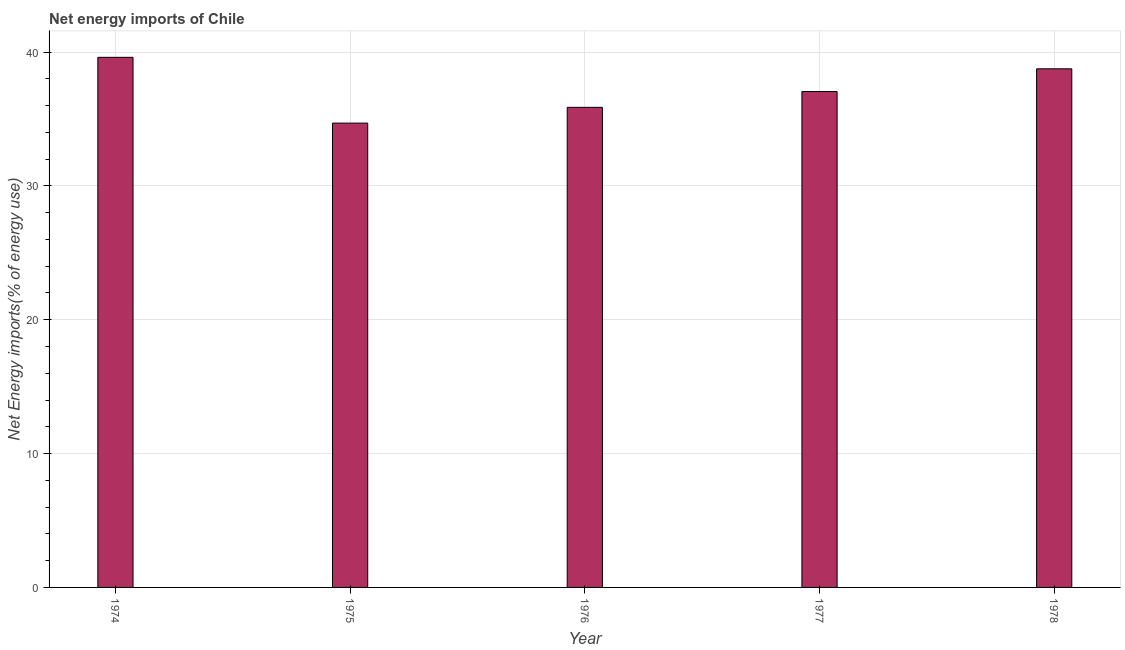Does the graph contain any zero values?
Your answer should be very brief. No. What is the title of the graph?
Your answer should be very brief. Net energy imports of Chile. What is the label or title of the X-axis?
Offer a terse response. Year. What is the label or title of the Y-axis?
Your answer should be very brief. Net Energy imports(% of energy use). What is the energy imports in 1976?
Your answer should be very brief. 35.87. Across all years, what is the maximum energy imports?
Your answer should be compact. 39.61. Across all years, what is the minimum energy imports?
Provide a succinct answer. 34.69. In which year was the energy imports maximum?
Your answer should be compact. 1974. In which year was the energy imports minimum?
Give a very brief answer. 1975. What is the sum of the energy imports?
Keep it short and to the point. 185.97. What is the difference between the energy imports in 1975 and 1978?
Give a very brief answer. -4.06. What is the average energy imports per year?
Provide a short and direct response. 37.19. What is the median energy imports?
Give a very brief answer. 37.05. In how many years, is the energy imports greater than 28 %?
Offer a very short reply. 5. What is the ratio of the energy imports in 1975 to that in 1978?
Give a very brief answer. 0.9. What is the difference between the highest and the second highest energy imports?
Your answer should be compact. 0.86. Is the sum of the energy imports in 1975 and 1978 greater than the maximum energy imports across all years?
Make the answer very short. Yes. What is the difference between the highest and the lowest energy imports?
Your response must be concise. 4.91. In how many years, is the energy imports greater than the average energy imports taken over all years?
Ensure brevity in your answer.  2. What is the difference between two consecutive major ticks on the Y-axis?
Make the answer very short. 10. Are the values on the major ticks of Y-axis written in scientific E-notation?
Provide a short and direct response. No. What is the Net Energy imports(% of energy use) of 1974?
Make the answer very short. 39.61. What is the Net Energy imports(% of energy use) in 1975?
Your response must be concise. 34.69. What is the Net Energy imports(% of energy use) in 1976?
Give a very brief answer. 35.87. What is the Net Energy imports(% of energy use) in 1977?
Your response must be concise. 37.05. What is the Net Energy imports(% of energy use) of 1978?
Provide a succinct answer. 38.75. What is the difference between the Net Energy imports(% of energy use) in 1974 and 1975?
Provide a succinct answer. 4.91. What is the difference between the Net Energy imports(% of energy use) in 1974 and 1976?
Give a very brief answer. 3.74. What is the difference between the Net Energy imports(% of energy use) in 1974 and 1977?
Offer a terse response. 2.56. What is the difference between the Net Energy imports(% of energy use) in 1974 and 1978?
Keep it short and to the point. 0.86. What is the difference between the Net Energy imports(% of energy use) in 1975 and 1976?
Your answer should be compact. -1.18. What is the difference between the Net Energy imports(% of energy use) in 1975 and 1977?
Keep it short and to the point. -2.36. What is the difference between the Net Energy imports(% of energy use) in 1975 and 1978?
Offer a very short reply. -4.06. What is the difference between the Net Energy imports(% of energy use) in 1976 and 1977?
Make the answer very short. -1.18. What is the difference between the Net Energy imports(% of energy use) in 1976 and 1978?
Keep it short and to the point. -2.88. What is the difference between the Net Energy imports(% of energy use) in 1977 and 1978?
Make the answer very short. -1.7. What is the ratio of the Net Energy imports(% of energy use) in 1974 to that in 1975?
Your answer should be very brief. 1.14. What is the ratio of the Net Energy imports(% of energy use) in 1974 to that in 1976?
Your response must be concise. 1.1. What is the ratio of the Net Energy imports(% of energy use) in 1974 to that in 1977?
Your answer should be very brief. 1.07. What is the ratio of the Net Energy imports(% of energy use) in 1975 to that in 1977?
Make the answer very short. 0.94. What is the ratio of the Net Energy imports(% of energy use) in 1975 to that in 1978?
Your response must be concise. 0.9. What is the ratio of the Net Energy imports(% of energy use) in 1976 to that in 1977?
Ensure brevity in your answer.  0.97. What is the ratio of the Net Energy imports(% of energy use) in 1976 to that in 1978?
Offer a very short reply. 0.93. What is the ratio of the Net Energy imports(% of energy use) in 1977 to that in 1978?
Your response must be concise. 0.96. 